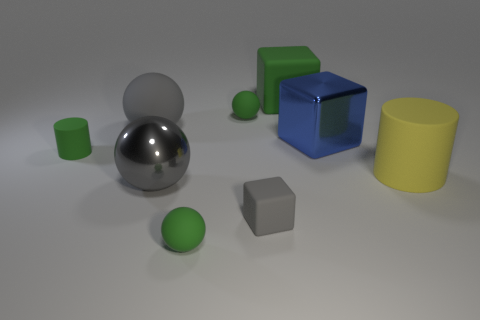Subtract all big cubes. How many cubes are left? 1 Subtract 2 spheres. How many spheres are left? 2 Add 1 large blue objects. How many objects exist? 10 Subtract all purple spheres. Subtract all yellow cubes. How many spheres are left? 4 Subtract all cylinders. How many objects are left? 7 Subtract all rubber things. Subtract all large red cubes. How many objects are left? 2 Add 2 gray shiny balls. How many gray shiny balls are left? 3 Add 8 tiny red rubber objects. How many tiny red rubber objects exist? 8 Subtract 0 brown cylinders. How many objects are left? 9 